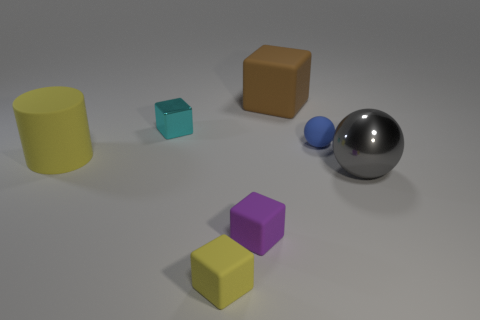Add 3 big blocks. How many objects exist? 10 Subtract all spheres. How many objects are left? 5 Add 3 big gray metal spheres. How many big gray metal spheres exist? 4 Subtract 0 brown spheres. How many objects are left? 7 Subtract all big gray metallic things. Subtract all cylinders. How many objects are left? 5 Add 5 purple things. How many purple things are left? 6 